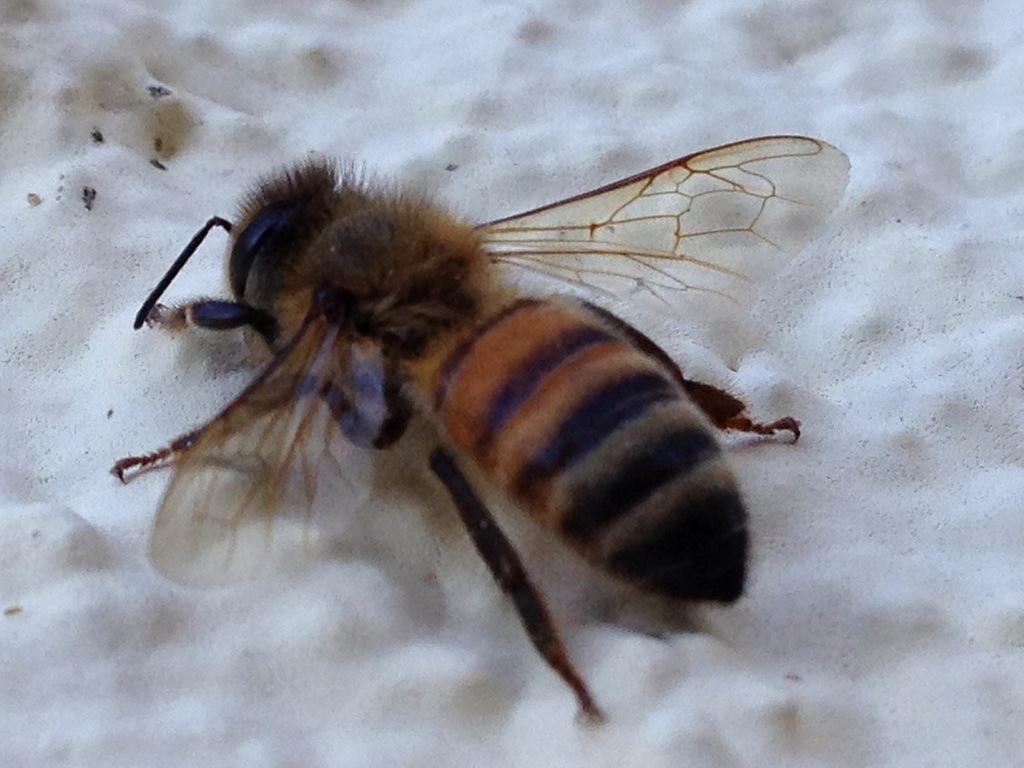Could you give a brief overview of what you see in this image? In this picture we can see an insect on a white surface. 